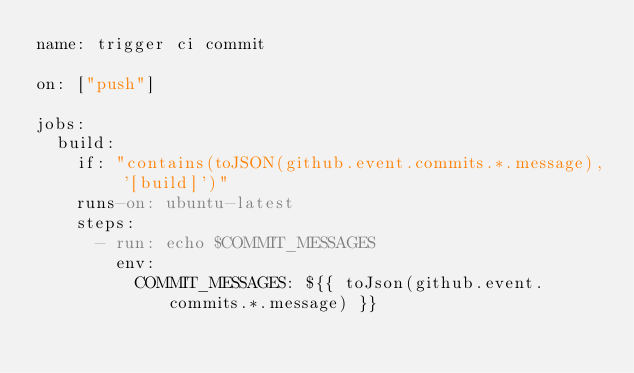Convert code to text. <code><loc_0><loc_0><loc_500><loc_500><_YAML_>name: trigger ci commit

on: ["push"]

jobs:
  build:
    if: "contains(toJSON(github.event.commits.*.message), '[build]')"
    runs-on: ubuntu-latest
    steps:
      - run: echo $COMMIT_MESSAGES
        env:
          COMMIT_MESSAGES: ${{ toJson(github.event.commits.*.message) }}
</code> 